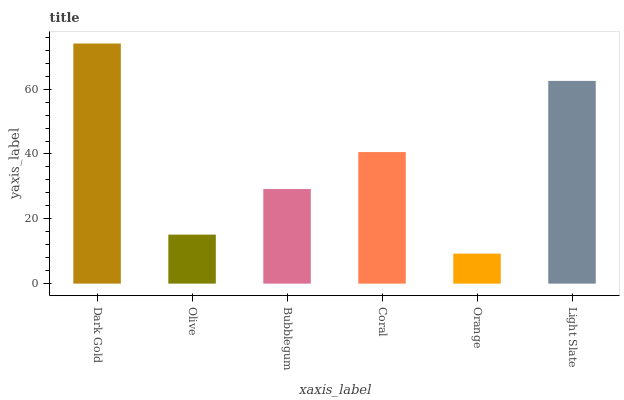Is Olive the minimum?
Answer yes or no. No. Is Olive the maximum?
Answer yes or no. No. Is Dark Gold greater than Olive?
Answer yes or no. Yes. Is Olive less than Dark Gold?
Answer yes or no. Yes. Is Olive greater than Dark Gold?
Answer yes or no. No. Is Dark Gold less than Olive?
Answer yes or no. No. Is Coral the high median?
Answer yes or no. Yes. Is Bubblegum the low median?
Answer yes or no. Yes. Is Dark Gold the high median?
Answer yes or no. No. Is Olive the low median?
Answer yes or no. No. 